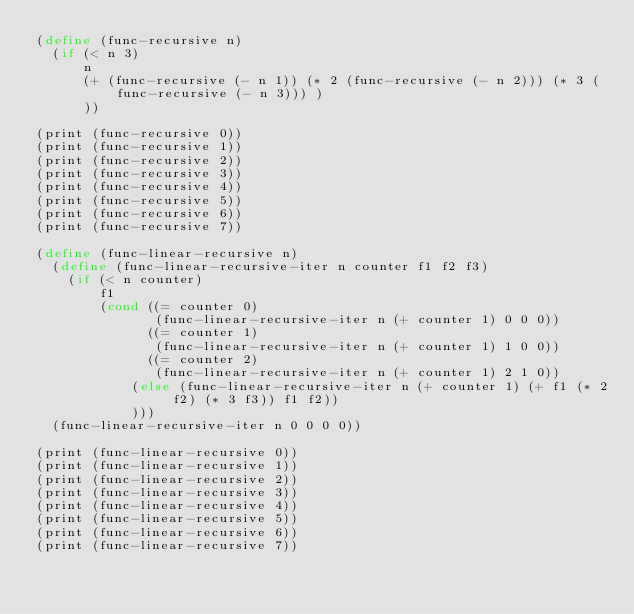<code> <loc_0><loc_0><loc_500><loc_500><_Scheme_>(define (func-recursive n)
  (if (< n 3)
      n
      (+ (func-recursive (- n 1)) (* 2 (func-recursive (- n 2))) (* 3 (func-recursive (- n 3))) )
      ))

(print (func-recursive 0))
(print (func-recursive 1))
(print (func-recursive 2))
(print (func-recursive 3))
(print (func-recursive 4))
(print (func-recursive 5))
(print (func-recursive 6))
(print (func-recursive 7))

(define (func-linear-recursive n)
  (define (func-linear-recursive-iter n counter f1 f2 f3)
    (if (< n counter)
        f1
        (cond ((= counter 0)
               (func-linear-recursive-iter n (+ counter 1) 0 0 0))
              ((= counter 1)
               (func-linear-recursive-iter n (+ counter 1) 1 0 0))
              ((= counter 2)
               (func-linear-recursive-iter n (+ counter 1) 2 1 0))
            (else (func-linear-recursive-iter n (+ counter 1) (+ f1 (* 2 f2) (* 3 f3)) f1 f2))
            )))
  (func-linear-recursive-iter n 0 0 0 0))

(print (func-linear-recursive 0))
(print (func-linear-recursive 1))
(print (func-linear-recursive 2))
(print (func-linear-recursive 3))
(print (func-linear-recursive 4))
(print (func-linear-recursive 5))
(print (func-linear-recursive 6))
(print (func-linear-recursive 7))
</code> 